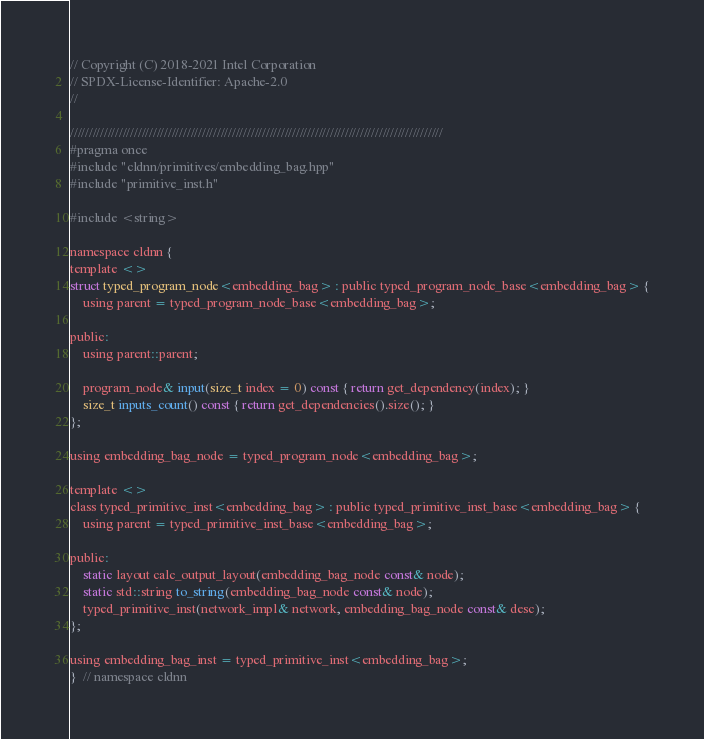<code> <loc_0><loc_0><loc_500><loc_500><_C_>// Copyright (C) 2018-2021 Intel Corporation
// SPDX-License-Identifier: Apache-2.0
//

///////////////////////////////////////////////////////////////////////////////////////////////////
#pragma once
#include "cldnn/primitives/embedding_bag.hpp"
#include "primitive_inst.h"

#include <string>

namespace cldnn {
template <>
struct typed_program_node<embedding_bag> : public typed_program_node_base<embedding_bag> {
    using parent = typed_program_node_base<embedding_bag>;

public:
    using parent::parent;

    program_node& input(size_t index = 0) const { return get_dependency(index); }
    size_t inputs_count() const { return get_dependencies().size(); }
};

using embedding_bag_node = typed_program_node<embedding_bag>;

template <>
class typed_primitive_inst<embedding_bag> : public typed_primitive_inst_base<embedding_bag> {
    using parent = typed_primitive_inst_base<embedding_bag>;

public:
    static layout calc_output_layout(embedding_bag_node const& node);
    static std::string to_string(embedding_bag_node const& node);
    typed_primitive_inst(network_impl& network, embedding_bag_node const& desc);
};

using embedding_bag_inst = typed_primitive_inst<embedding_bag>;
}  // namespace cldnn
</code> 